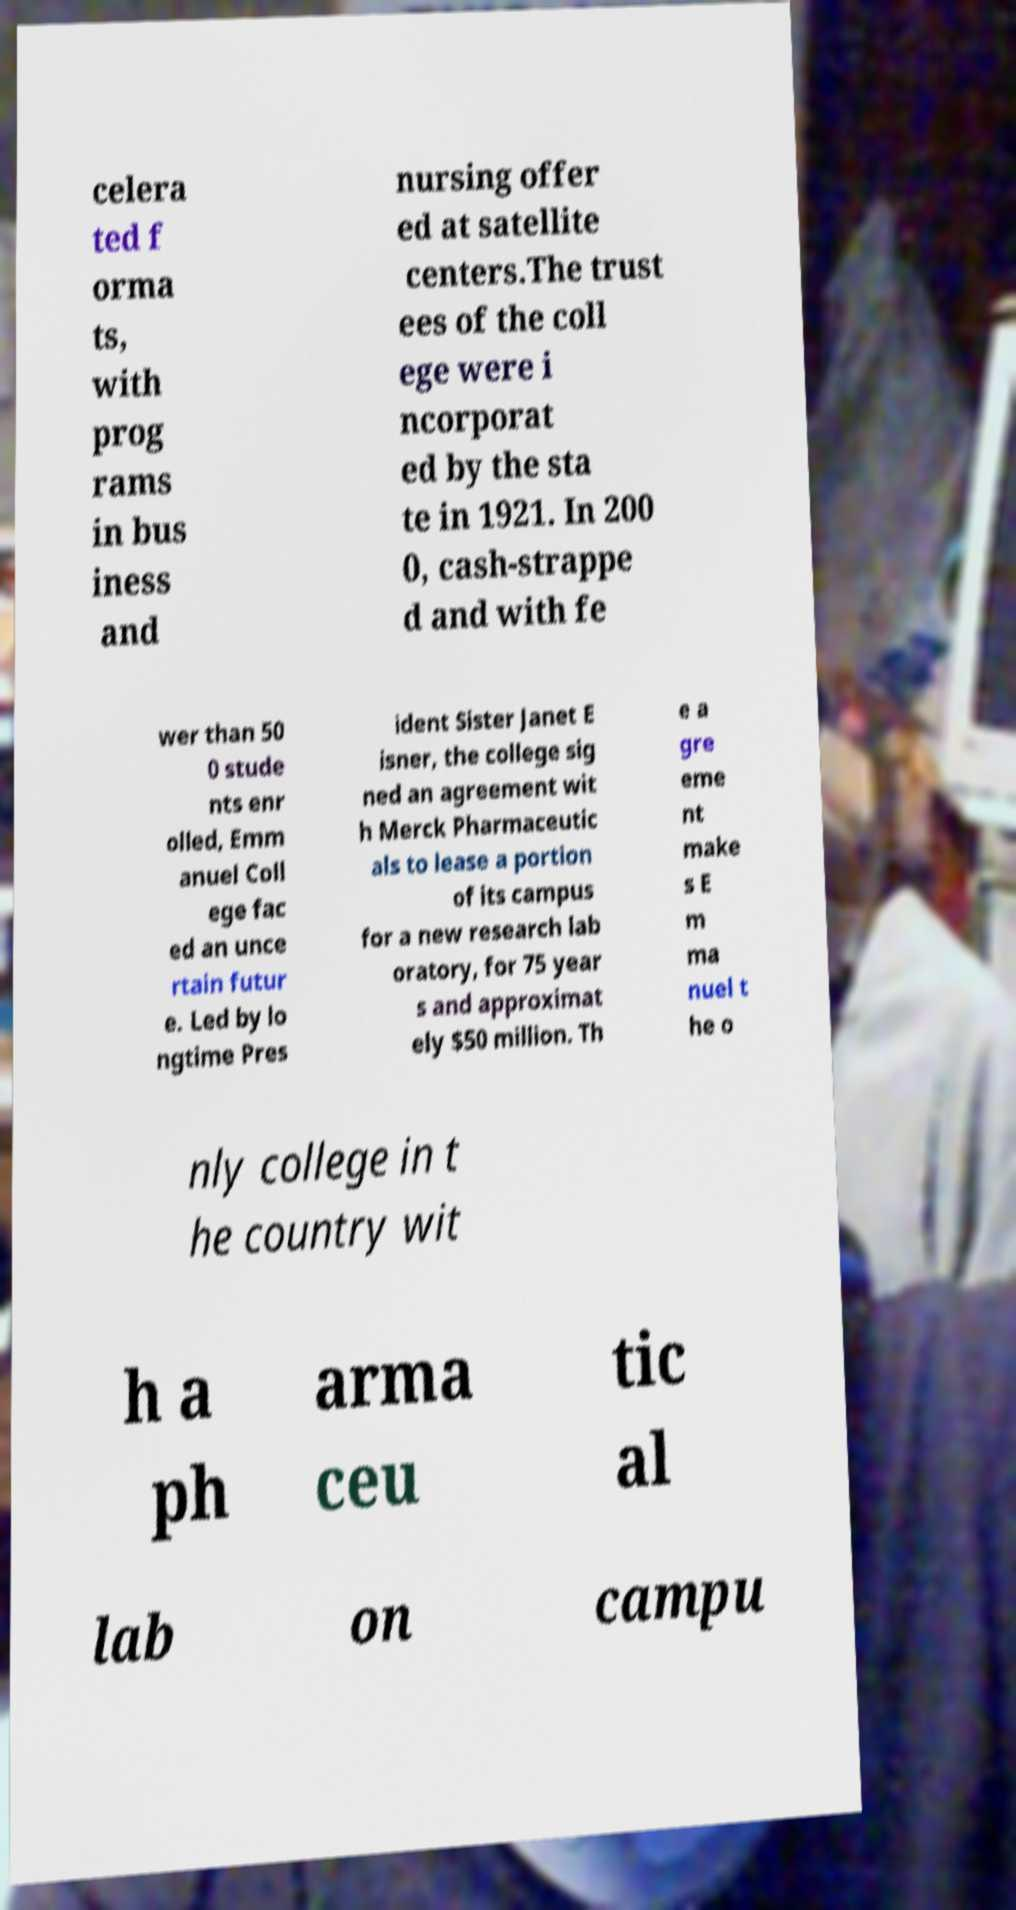Can you accurately transcribe the text from the provided image for me? celera ted f orma ts, with prog rams in bus iness and nursing offer ed at satellite centers.The trust ees of the coll ege were i ncorporat ed by the sta te in 1921. In 200 0, cash-strappe d and with fe wer than 50 0 stude nts enr olled, Emm anuel Coll ege fac ed an unce rtain futur e. Led by lo ngtime Pres ident Sister Janet E isner, the college sig ned an agreement wit h Merck Pharmaceutic als to lease a portion of its campus for a new research lab oratory, for 75 year s and approximat ely $50 million. Th e a gre eme nt make s E m ma nuel t he o nly college in t he country wit h a ph arma ceu tic al lab on campu 